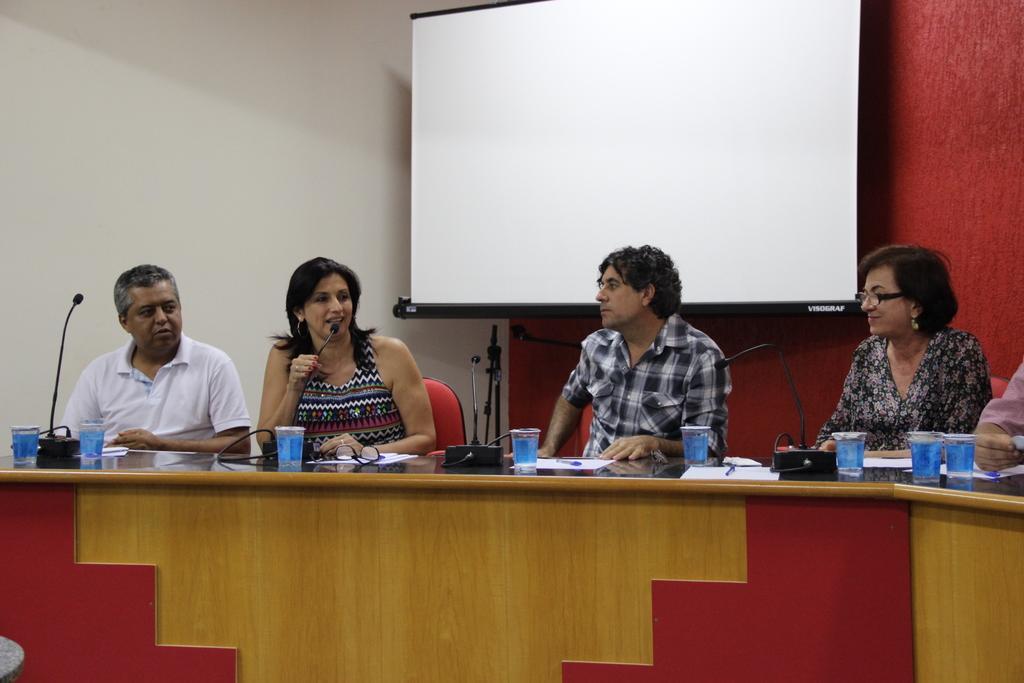Can you describe this image briefly? In this picture I can see four persons sitting on the cars, there are mike's, glasses, papers, pens on the table, there is a projector screen, and in the background there is a wall. 